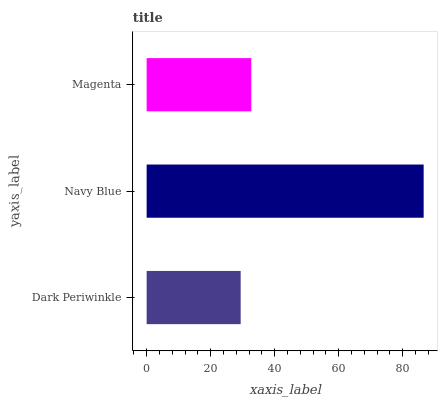Is Dark Periwinkle the minimum?
Answer yes or no. Yes. Is Navy Blue the maximum?
Answer yes or no. Yes. Is Magenta the minimum?
Answer yes or no. No. Is Magenta the maximum?
Answer yes or no. No. Is Navy Blue greater than Magenta?
Answer yes or no. Yes. Is Magenta less than Navy Blue?
Answer yes or no. Yes. Is Magenta greater than Navy Blue?
Answer yes or no. No. Is Navy Blue less than Magenta?
Answer yes or no. No. Is Magenta the high median?
Answer yes or no. Yes. Is Magenta the low median?
Answer yes or no. Yes. Is Navy Blue the high median?
Answer yes or no. No. Is Dark Periwinkle the low median?
Answer yes or no. No. 